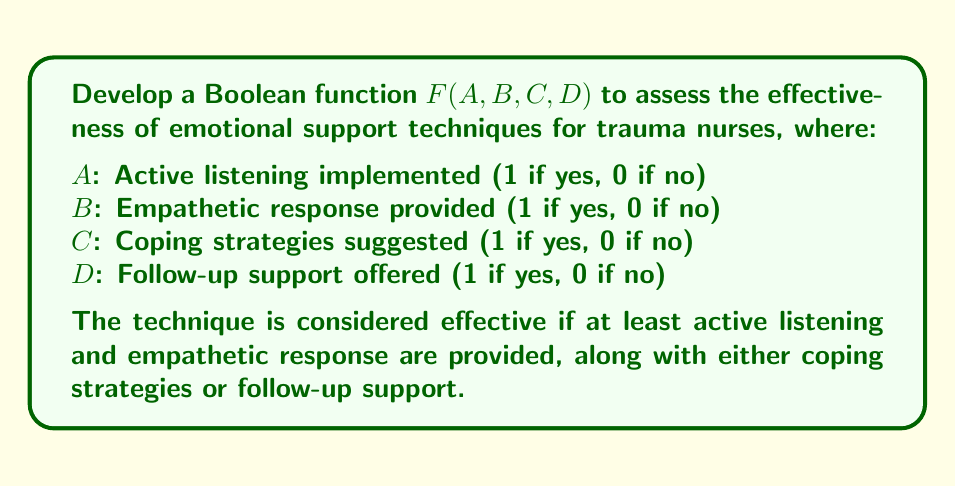Provide a solution to this math problem. To develop the Boolean function, we need to translate the given conditions into logical operations:

1. Active listening (A) AND empathetic response (B) must be present:
   $A \cdot B$

2. Either coping strategies (C) OR follow-up support (D) must be present:
   $C + D$

3. Combine these conditions using AND:
   $F(A,B,C,D) = (A \cdot B) \cdot (C + D)$

4. Expand the expression using distributive property:
   $F(A,B,C,D) = (A \cdot B \cdot C) + (A \cdot B \cdot D)$

This Boolean function will evaluate to 1 (true) when the emotional support technique is effective according to the given criteria, and 0 (false) otherwise.

To verify:
- If $A=1$, $B=1$, $C=1$, $D=0$: $F = (1 \cdot 1 \cdot 1) + (1 \cdot 1 \cdot 0) = 1 + 0 = 1$ (effective)
- If $A=1$, $B=1$, $C=0$, $D=1$: $F = (1 \cdot 1 \cdot 0) + (1 \cdot 1 \cdot 1) = 0 + 1 = 1$ (effective)
- If $A=1$, $B=0$, $C=1$, $D=1$: $F = (1 \cdot 0 \cdot 1) + (1 \cdot 0 \cdot 1) = 0 + 0 = 0$ (not effective)
Answer: $F(A,B,C,D) = (A \cdot B \cdot C) + (A \cdot B \cdot D)$ 